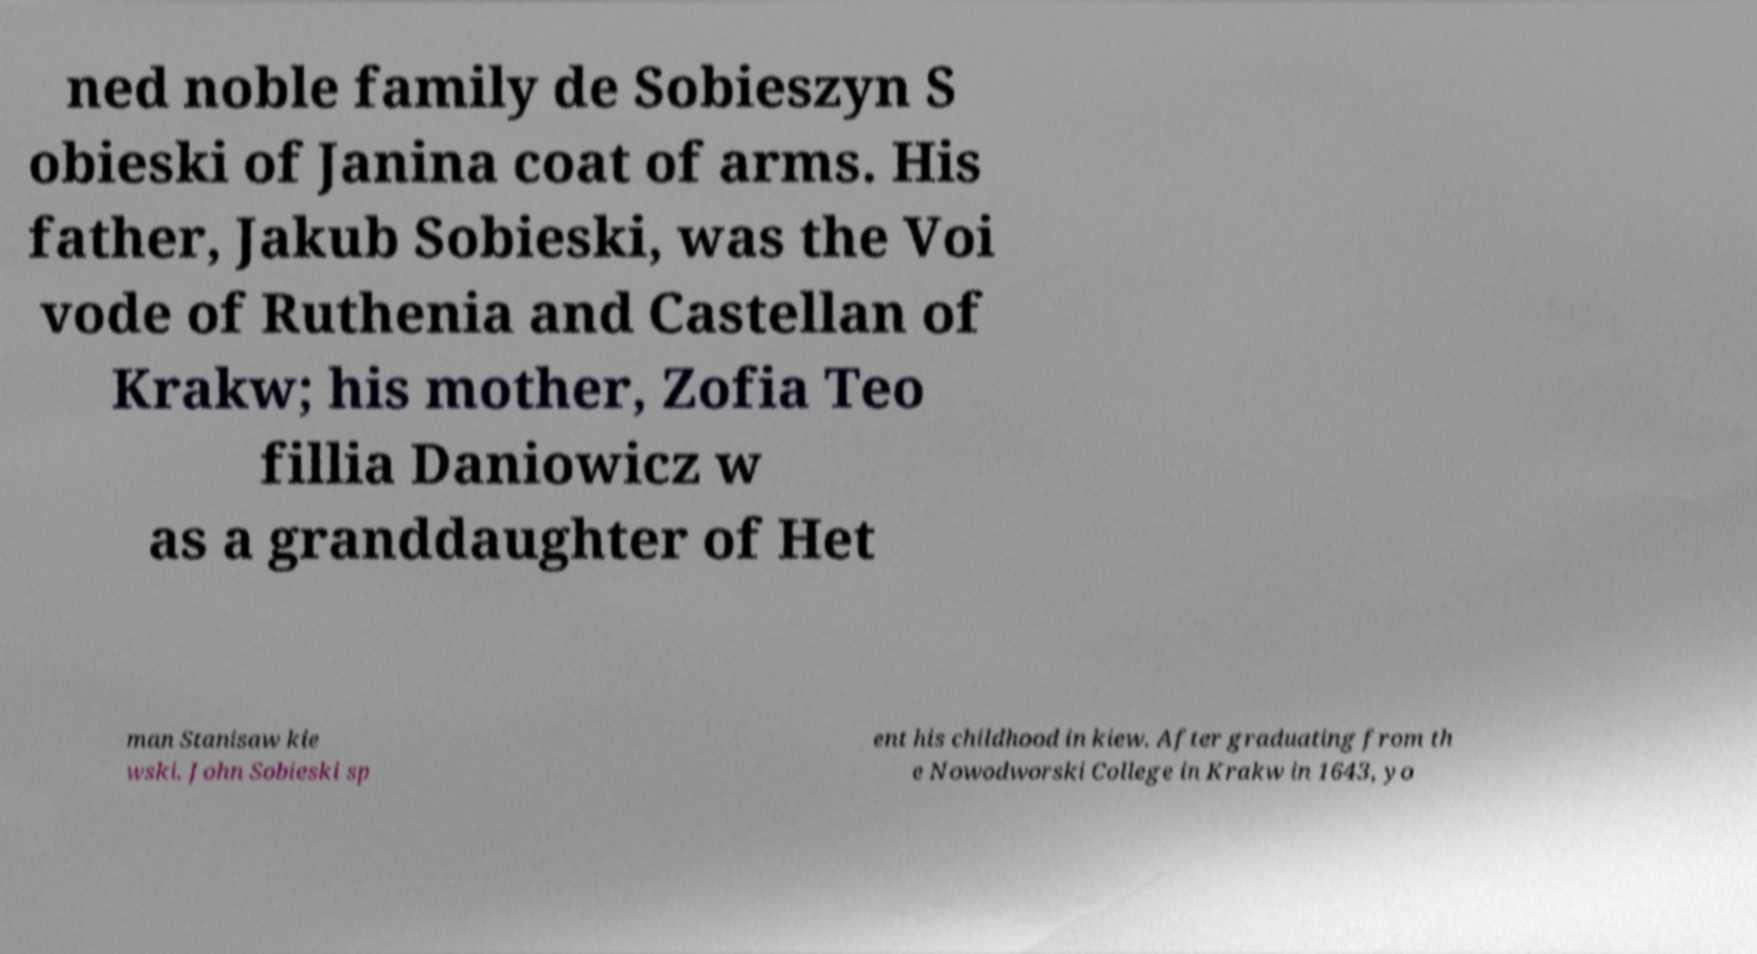There's text embedded in this image that I need extracted. Can you transcribe it verbatim? ned noble family de Sobieszyn S obieski of Janina coat of arms. His father, Jakub Sobieski, was the Voi vode of Ruthenia and Castellan of Krakw; his mother, Zofia Teo fillia Daniowicz w as a granddaughter of Het man Stanisaw kie wski. John Sobieski sp ent his childhood in kiew. After graduating from th e Nowodworski College in Krakw in 1643, yo 